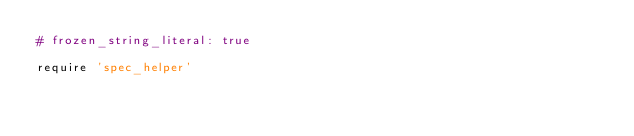Convert code to text. <code><loc_0><loc_0><loc_500><loc_500><_Ruby_># frozen_string_literal: true

require 'spec_helper'
</code> 